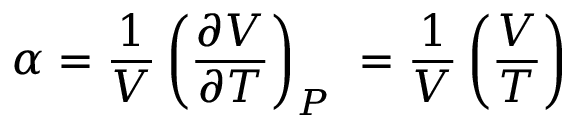<formula> <loc_0><loc_0><loc_500><loc_500>\alpha = { \frac { 1 } { V } } \left ( { \frac { \partial V } { \partial T } } \right ) _ { P } \ = { \frac { 1 } { V } } \left ( { \frac { V } { T } } \right )</formula> 